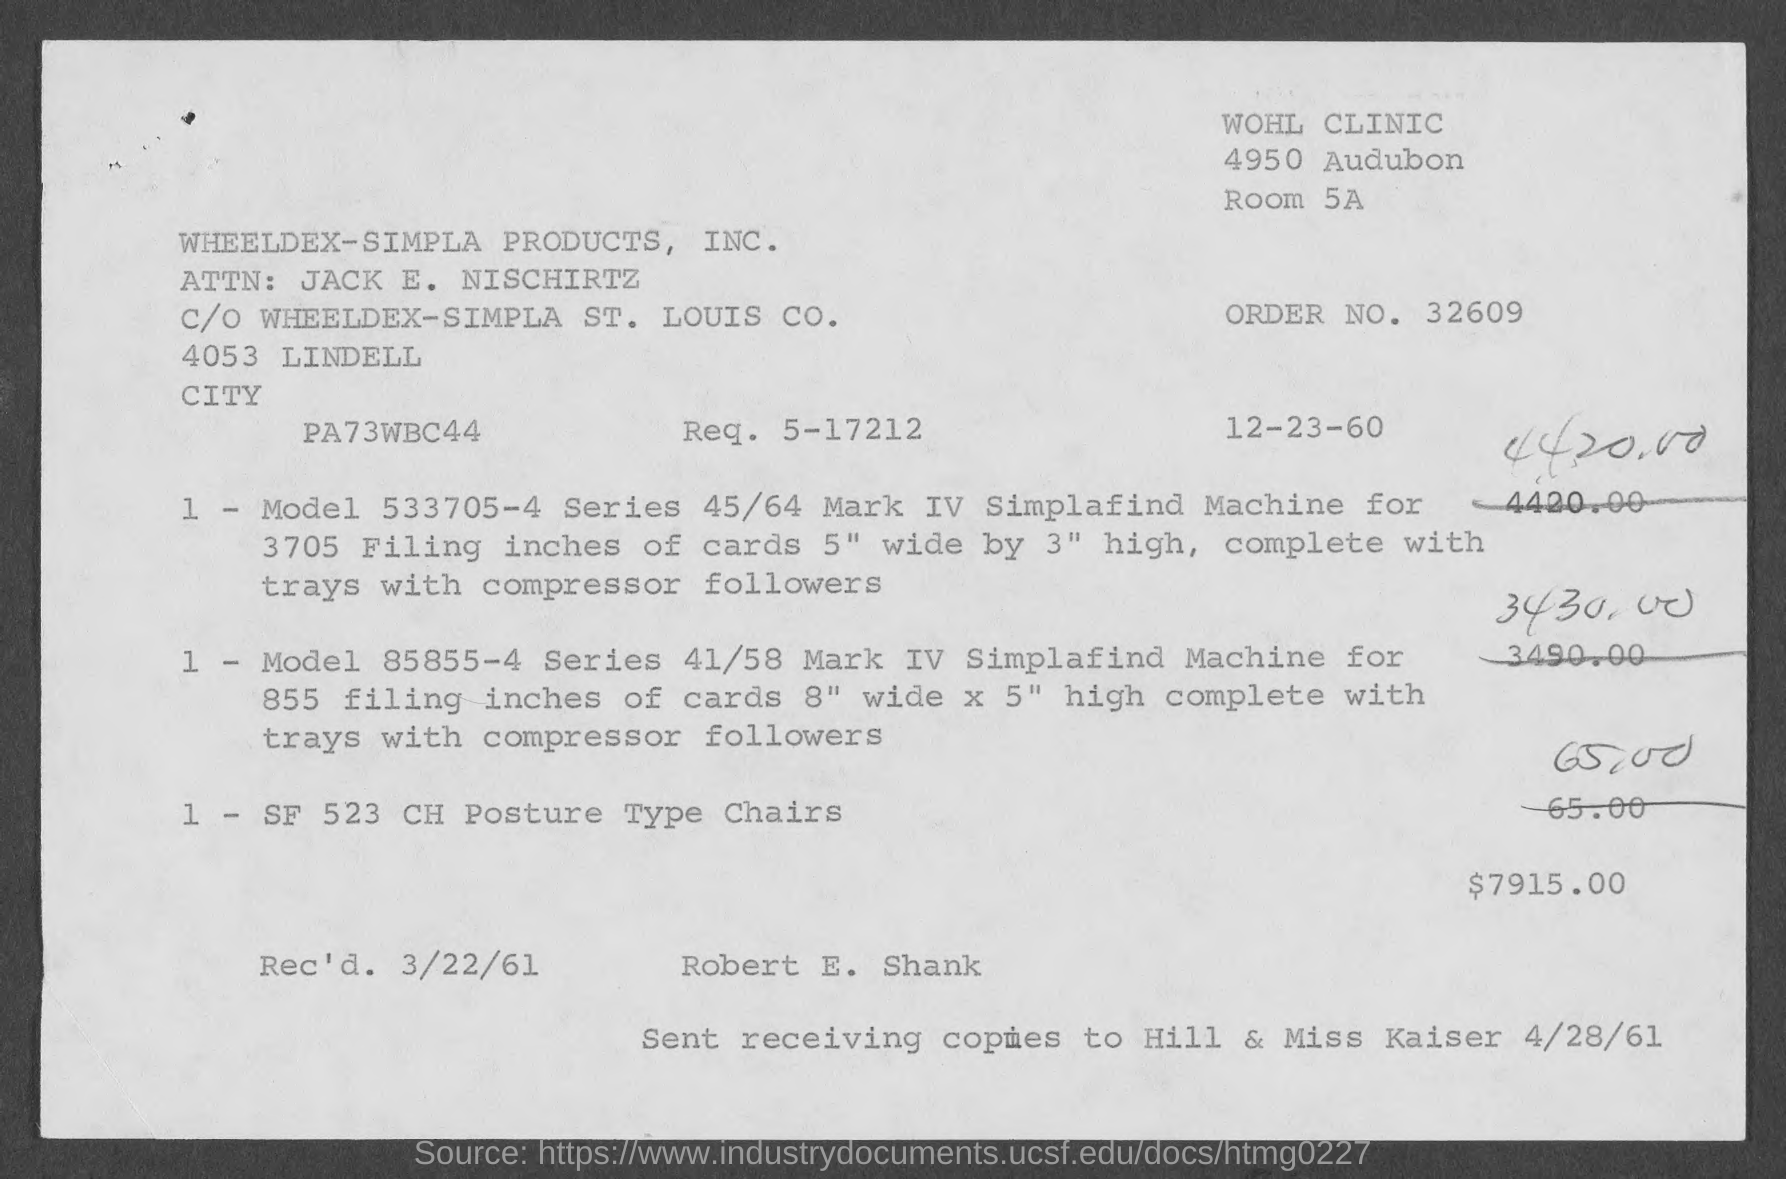Mention a couple of crucial points in this snapshot. The order number is 32609... The room number is 5A. 